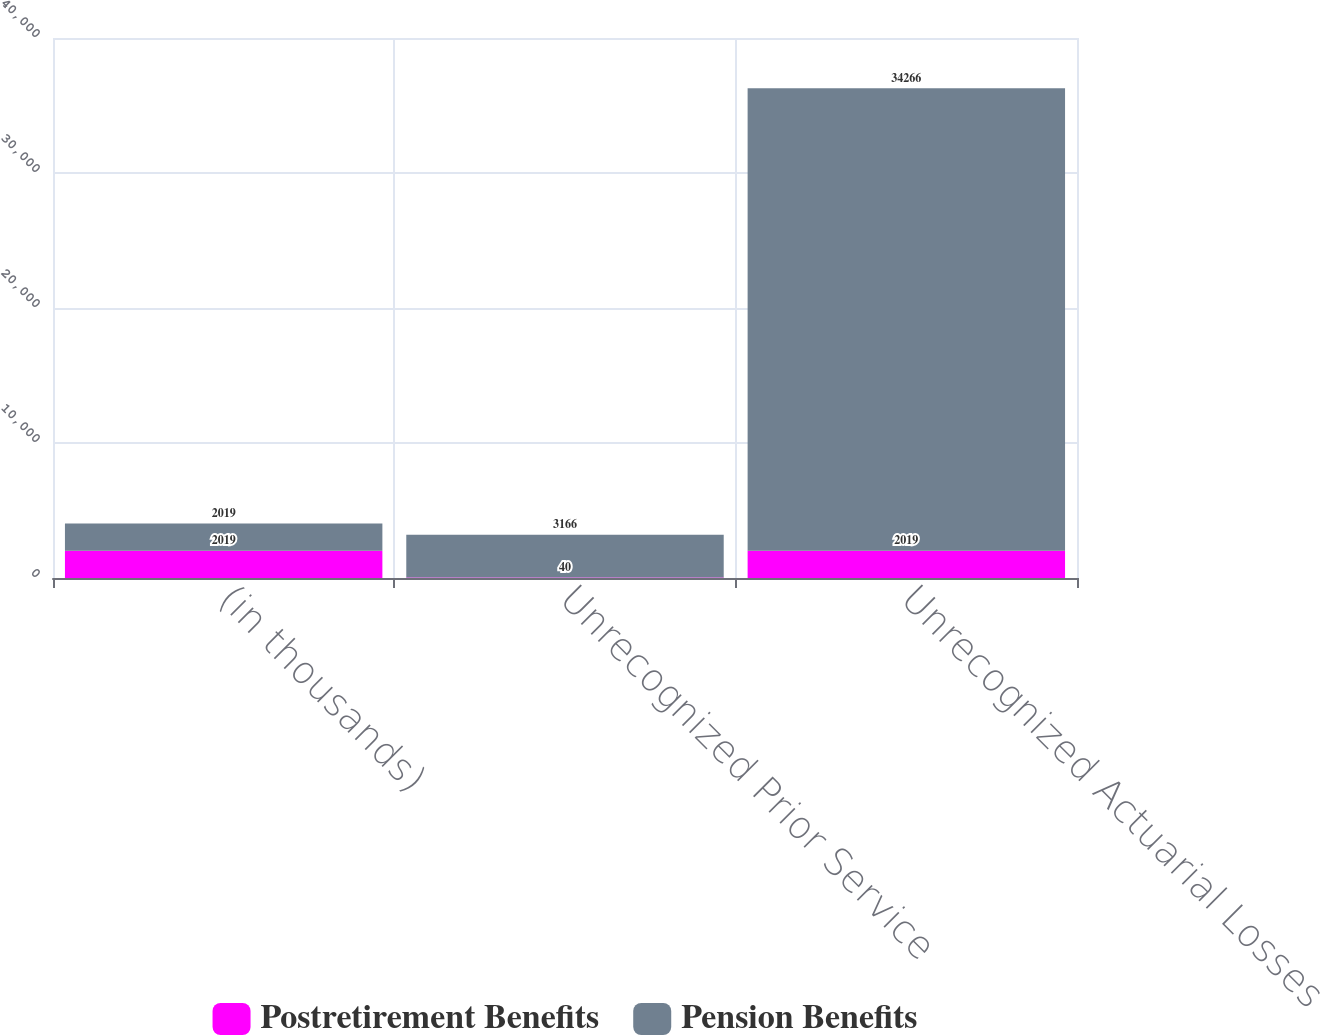<chart> <loc_0><loc_0><loc_500><loc_500><stacked_bar_chart><ecel><fcel>(in thousands)<fcel>Unrecognized Prior Service<fcel>Unrecognized Actuarial Losses<nl><fcel>Postretirement Benefits<fcel>2019<fcel>40<fcel>2019<nl><fcel>Pension Benefits<fcel>2019<fcel>3166<fcel>34266<nl></chart> 